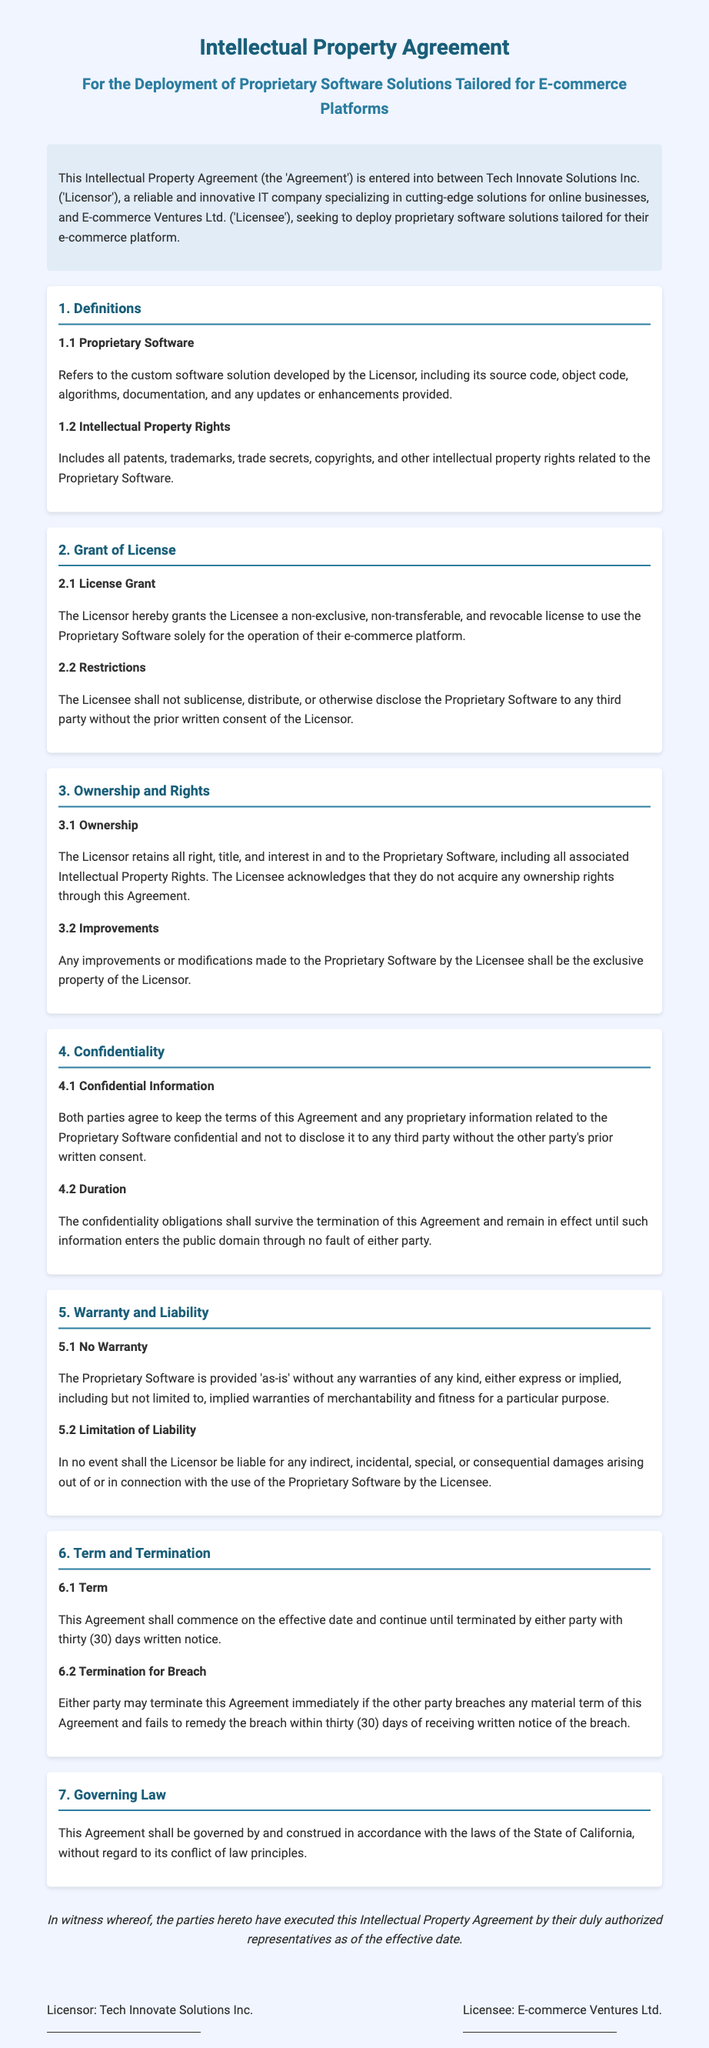What is the name of the Licensor? The Licensor is Tech Innovate Solutions Inc. as stated in the introduction of the document.
Answer: Tech Innovate Solutions Inc What is the term for termination notice? The document specifies a thirty (30) days written notice for termination, found under the Term and Termination section.
Answer: thirty (30) days What type of license is granted? The license granted to the Licensee is non-exclusive, non-transferable, and revocable, mentioned in the Grant of License section.
Answer: non-exclusive, non-transferable, and revocable What does the Licensor retain? The Licensor retains all right, title, and interest in the Proprietary Software, as stated in the Ownership and Rights section.
Answer: all right, title, and interest What must both parties maintain regarding the agreement? Both parties agree to keep the terms of the Agreement confidential, as indicated in the Confidentiality section.
Answer: confidentiality Under which law is the Agreement governed? The Agreement is governed by the laws of the State of California, mentioned in the Governing Law section.
Answer: State of California What is the warranty in the document? The document states that the Proprietary Software is provided 'as-is' without any warranties, as found in the Warranty and Liability section.
Answer: 'as-is' What happens to improvements made by the Licensee? Any improvements made by the Licensee shall be the exclusive property of the Licensor, stated in the Ownership and Rights section.
Answer: exclusive property of the Licensor What is the effective date? The Agreement does not specify the effective date; it has to be determined upon signing.
Answer: Not specified 